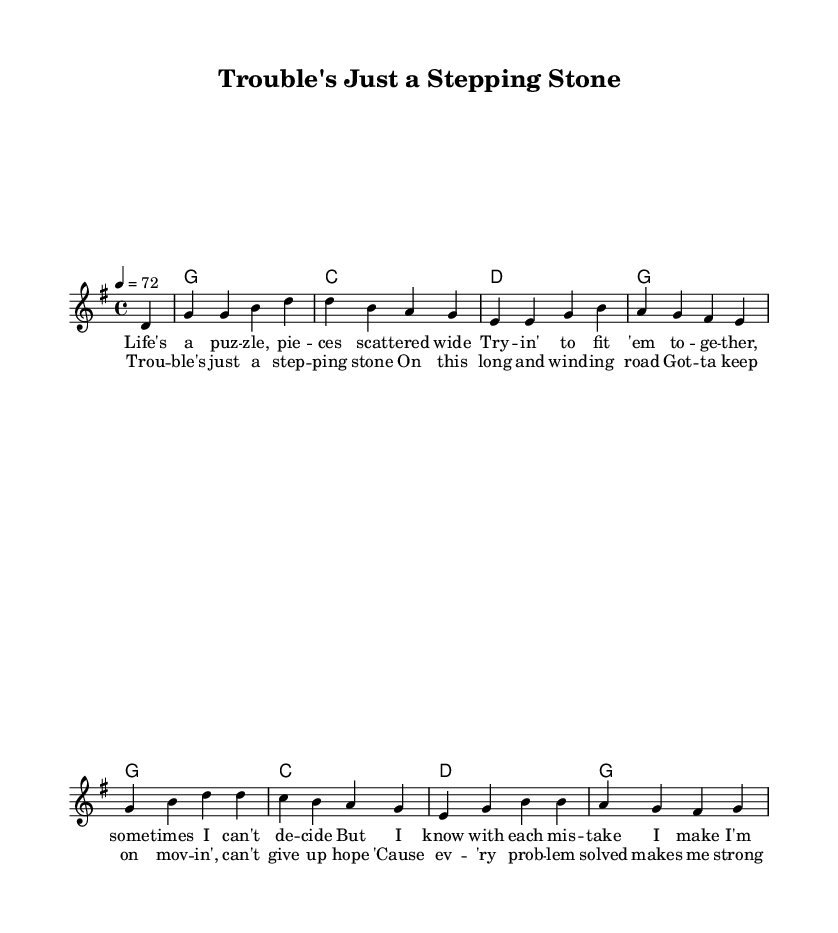What is the key signature of this music? The key signature is G major, which has one sharp (F#). This is indicated at the beginning of the score.
Answer: G major What is the time signature of this music? The time signature is 4/4, which is shown at the start of the piece and indicates there are four beats per measure.
Answer: 4/4 What is the tempo marking of this music? The tempo marking is 4 = 72, indicating that there are 72 quarter note beats per minute. This information is found in the global context section.
Answer: 72 How many measures are in the verse? There are four measures in the verse section, which can be counted by looking at the segments of music corresponding to the lyrics provided.
Answer: 4 What is the primary theme reflected in the lyrics? The primary theme is perseverance through challenges, as indicated by phrases like "trouble's just a stepping stone" which suggest overcoming obstacles and maintaining hope. This understanding comes from analyzing the lyrical content.
Answer: Perseverance How many chords are played in the chorus? There are four chords specified in the chorus section: G, C, D, and G. Each chord corresponds to the lines of lyrics, indicating harmonic support.
Answer: 4 What musical form does this piece reflect? The musical form reflects a verse-chorus structure, which is common in country ballads, as seen in the clear separation of verses and choruses throughout the score.
Answer: Verse-chorus 